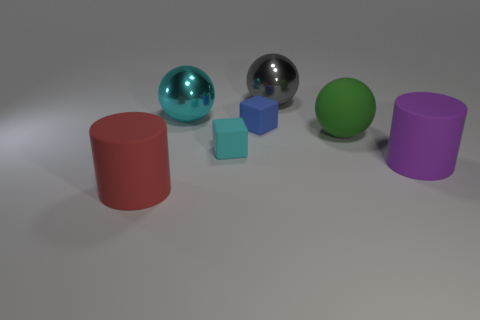Subtract all big green rubber balls. How many balls are left? 2 Add 2 large gray shiny balls. How many objects exist? 9 Subtract all blocks. How many objects are left? 5 Subtract 2 spheres. How many spheres are left? 1 Subtract all brown cubes. Subtract all gray cylinders. How many cubes are left? 2 Subtract all large spheres. Subtract all large shiny balls. How many objects are left? 2 Add 4 gray balls. How many gray balls are left? 5 Add 3 large metal objects. How many large metal objects exist? 5 Subtract all purple cylinders. How many cylinders are left? 1 Subtract 1 cyan balls. How many objects are left? 6 